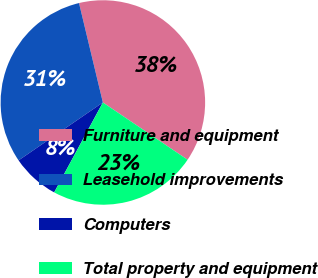Convert chart. <chart><loc_0><loc_0><loc_500><loc_500><pie_chart><fcel>Furniture and equipment<fcel>Leasehold improvements<fcel>Computers<fcel>Total property and equipment<nl><fcel>38.21%<fcel>30.83%<fcel>7.52%<fcel>23.44%<nl></chart> 